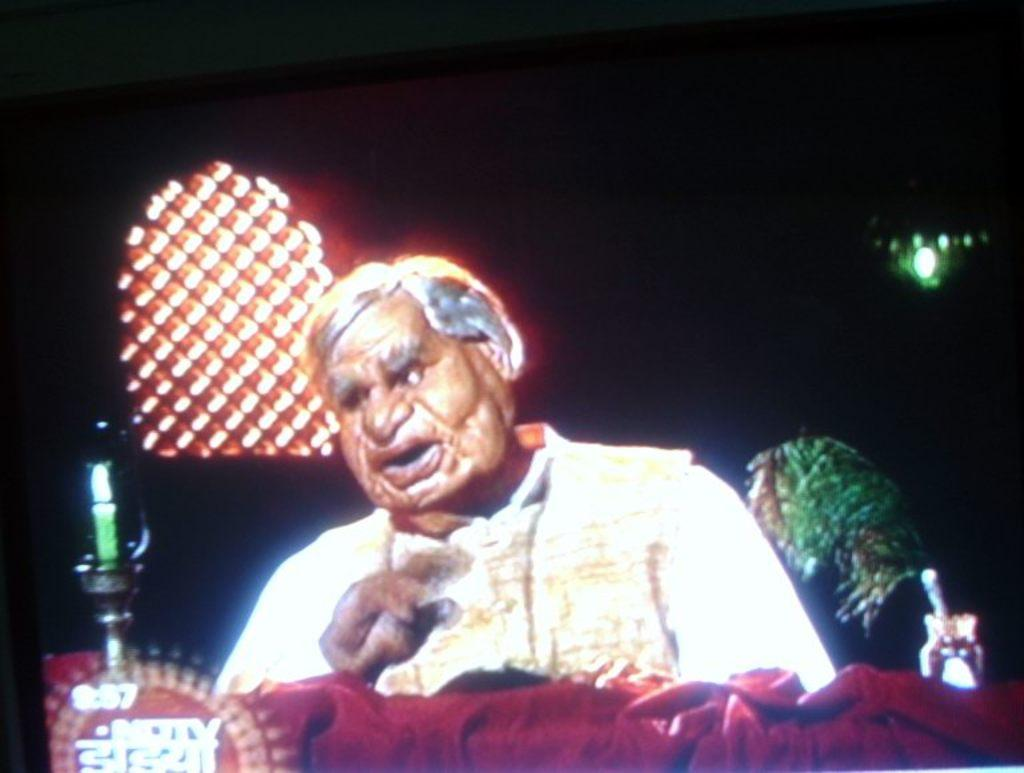What is the main subject in the image? There is a doll in the image. What is the doll wearing? The doll is wearing a dress. Can you describe the doll's hair? The doll has grey hair. What is present in the foreground of the image? There is a red cloth in the foreground. What is placed on the red cloth? A bottle is placed on the red cloth. What can be seen in the background of the image? There is a window in the background. What is visible through the window? There is a tree visible through the window. What color is the orange in the image? There is no orange present in the image. What type of exchange is taking place between the doll and the tree? There is no exchange taking place between the doll and the tree, as they are separate objects in the image. 